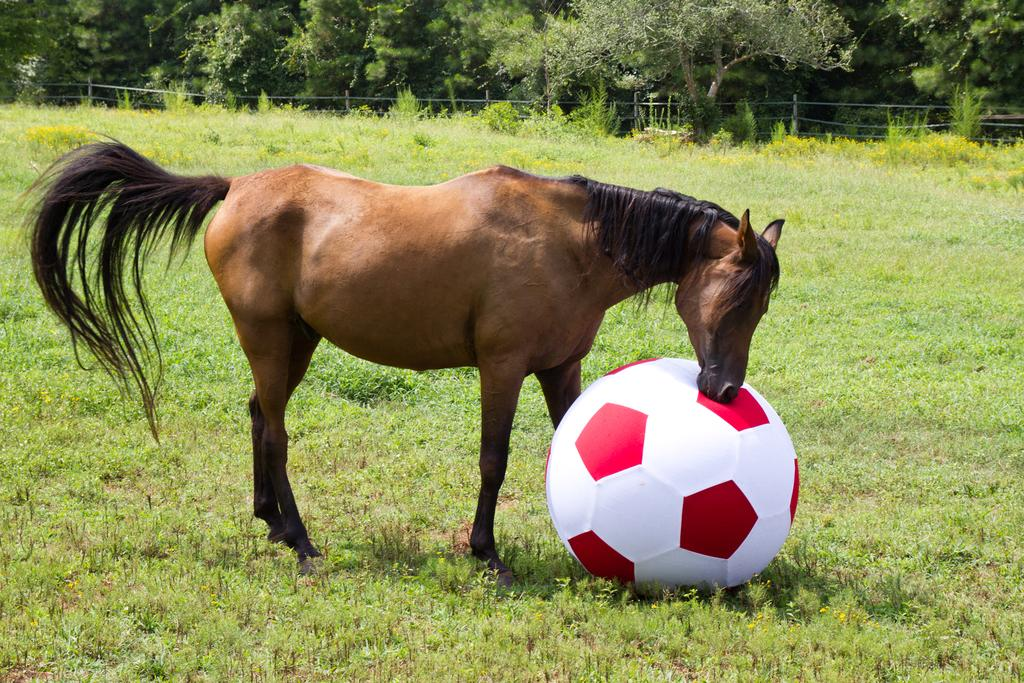What is the main subject in the center of the image? There is a horse in the center of the image. What else is located in the center of the image? There is a ball in the center of the image. What can be seen in the background of the image? There are plants, trees, and fencing in the background of the image. What is visible at the bottom of the image? The ground is visible at the bottom of the image. How does the horse contribute to the expansion of the lace industry in the image? There is no mention of lace or the lace industry in the image, and the horse is not involved in any such activity. What type of trains can be seen passing by in the image? There are no trains present in the image. 